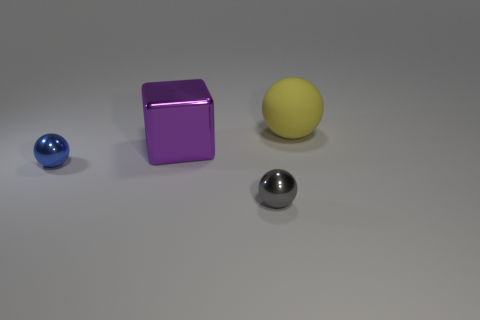Add 4 small blue things. How many objects exist? 8 Subtract all cubes. How many objects are left? 3 Add 1 yellow balls. How many yellow balls are left? 2 Add 4 blue balls. How many blue balls exist? 5 Subtract 0 green blocks. How many objects are left? 4 Subtract all big blue spheres. Subtract all tiny things. How many objects are left? 2 